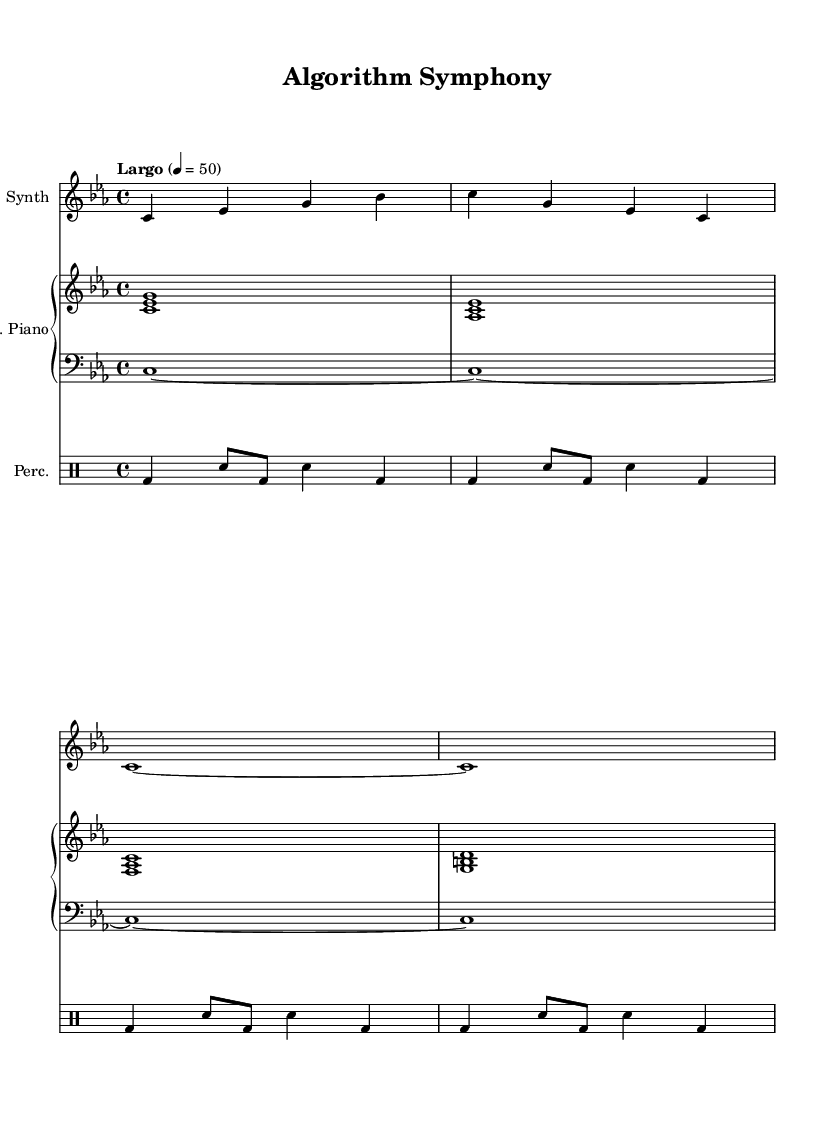What is the key signature of this music? The key signature indicates that the music is in C minor, which includes three flats: B flat, E flat, and A flat. This can be determined by observing the flat signs placed on the staff at the beginning of the piece.
Answer: C minor What is the time signature of this music? The time signature is indicated right after the key signature. In this case, it shows 4/4, meaning there are four beats per measure and a quarter note gets one beat. This can be identified by looking at the numbers at the beginning of the piece, showing the measure structure.
Answer: 4/4 What is the tempo marking for this piece? The tempo marking states "Largo," which indicates a slow tempo. The exact beats per minute (BPM) given is 50, and you can find this information directly below the tempo marking at the start of the music.
Answer: Largo, 50 How many measures are present in the synth part? The synth part is made up of four measures, which can be determined by counting the vertical lines (bar lines) that separate the music into groups. Each measurement corresponds to a group of beats as defined by the time signature.
Answer: 4 What is the rhythmic pattern of the percussion part? The percussion part features a consistent alternating pattern of bass drum and snare hits throughout the measures. You can deduce this by analyzing the written drumming notation, which shows how the drum hits are organized across each measure.
Answer: Alternating bass and snare Which instrument plays the lowest notes? The instrument playing the lowest notes in this score is the bass drone, which is notated in the bass clef and sustains long notes throughout. This can be identified by observing the bottom staff in the score where the notes are placed lower on the staff compared to other instruments.
Answer: Bass drone What type of harmony is used in the piano part? The piano part primarily features simple triads built on different chords throughout the measures. You can check this by looking at the note groupings (chord shapes) present within the piano staff.
Answer: Triadic harmony 